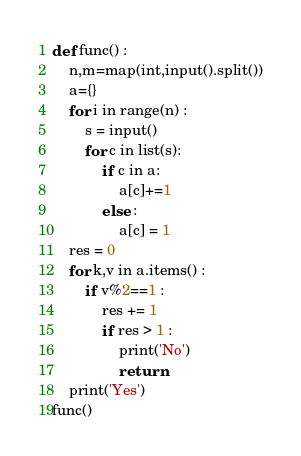Convert code to text. <code><loc_0><loc_0><loc_500><loc_500><_Python_>def func() :
    n,m=map(int,input().split())
    a={}
    for i in range(n) :
        s = input()
        for c in list(s):
            if c in a:
                a[c]+=1
            else :
                a[c] = 1
    res = 0
    for k,v in a.items() :
        if v%2==1 :
            res += 1
            if res > 1 :
                print('No')
                return
    print('Yes')
func()</code> 